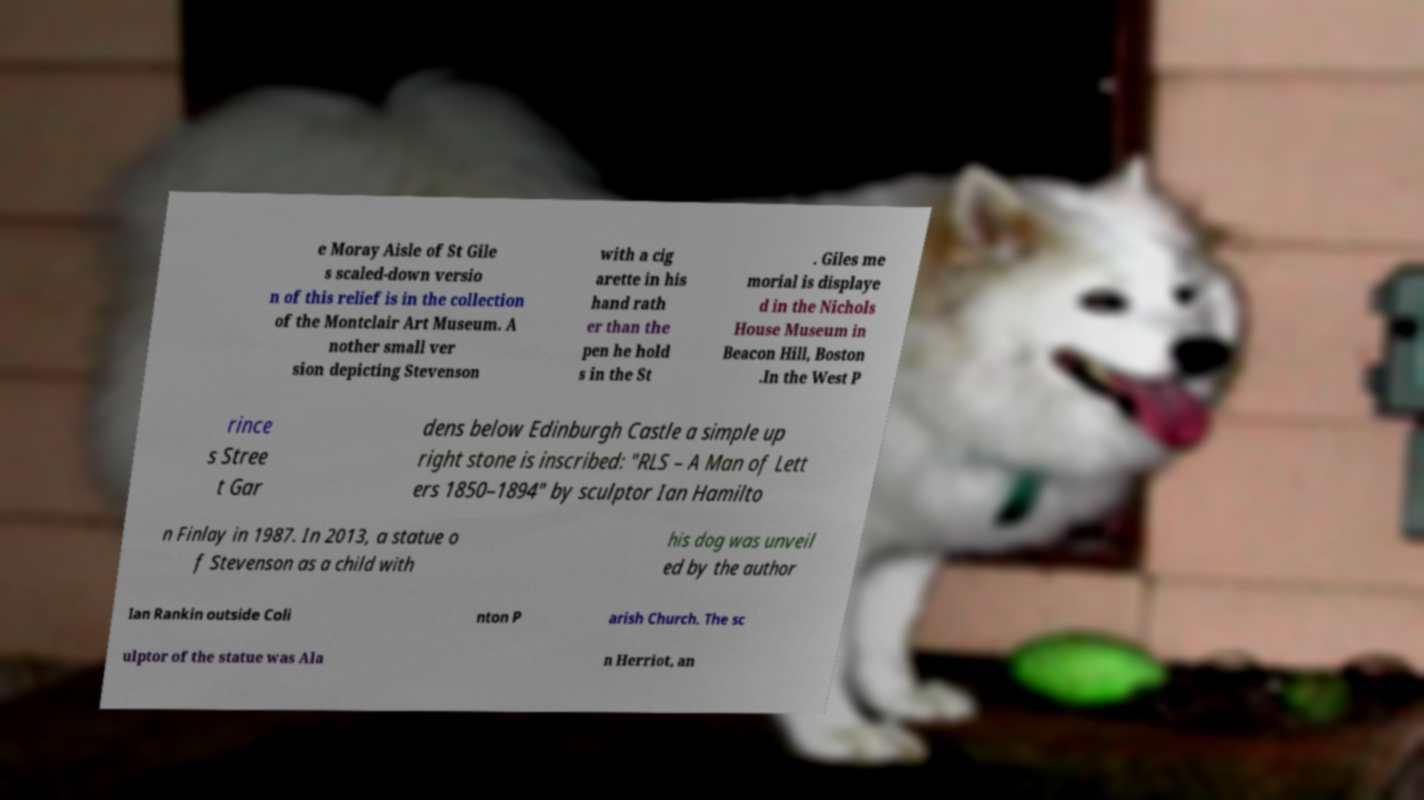For documentation purposes, I need the text within this image transcribed. Could you provide that? e Moray Aisle of St Gile s scaled-down versio n of this relief is in the collection of the Montclair Art Museum. A nother small ver sion depicting Stevenson with a cig arette in his hand rath er than the pen he hold s in the St . Giles me morial is displaye d in the Nichols House Museum in Beacon Hill, Boston .In the West P rince s Stree t Gar dens below Edinburgh Castle a simple up right stone is inscribed: "RLS – A Man of Lett ers 1850–1894" by sculptor Ian Hamilto n Finlay in 1987. In 2013, a statue o f Stevenson as a child with his dog was unveil ed by the author Ian Rankin outside Coli nton P arish Church. The sc ulptor of the statue was Ala n Herriot, an 